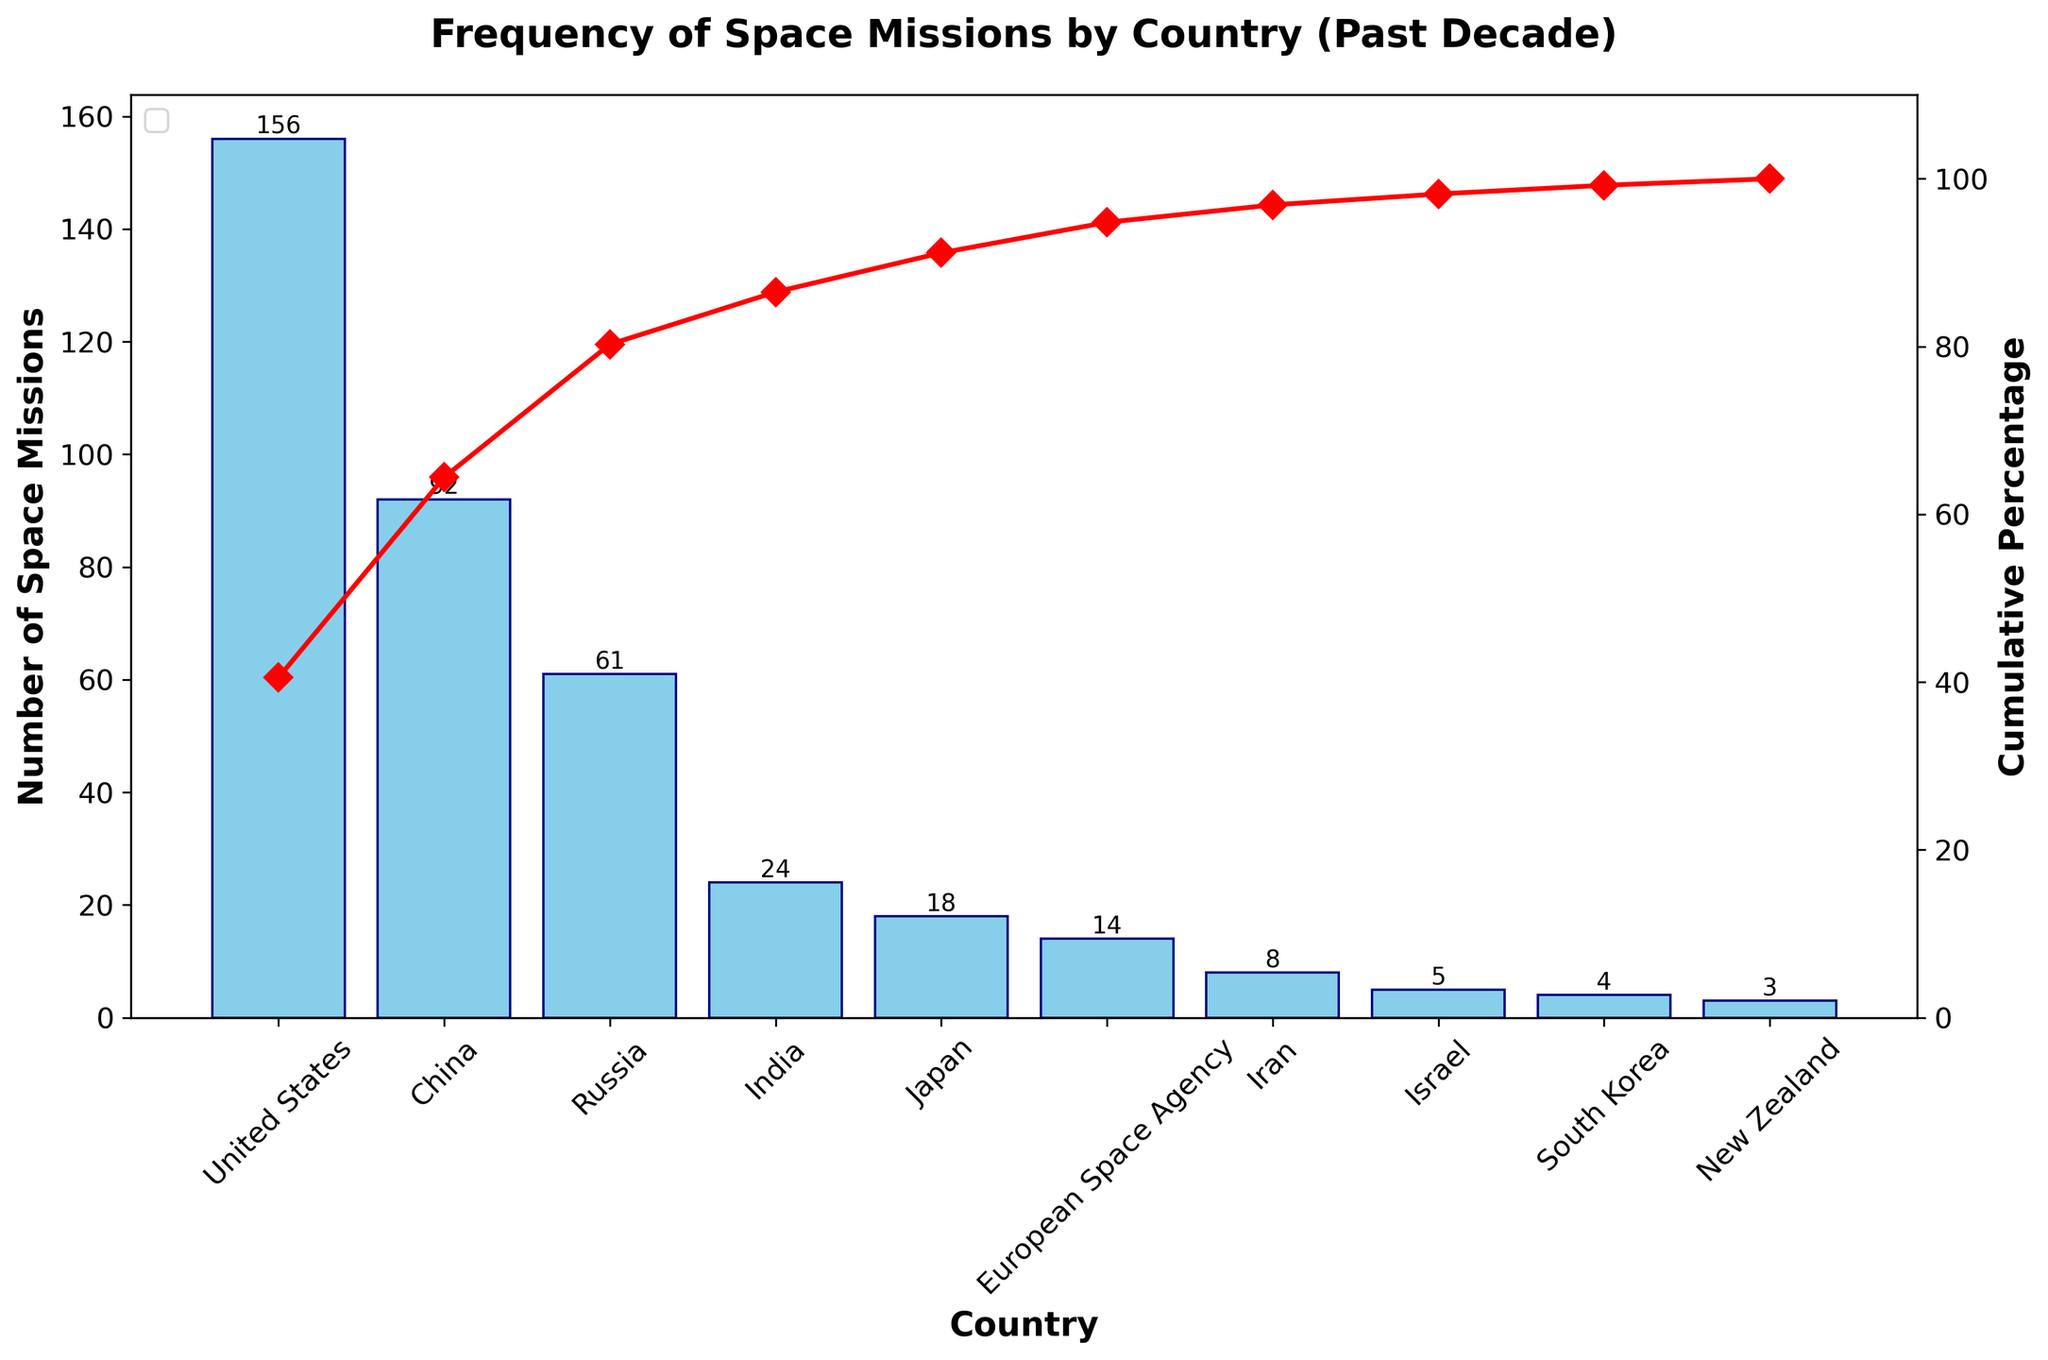How many countries are represented in the chart? Count the number of unique countries listed on the x-axis of the bar chart
Answer: 10 Which country has the highest number of space missions? Identify the tallest bar in the bar chart which corresponds to the United States
Answer: United States What is the cumulative percentage of space missions contributed by the top three countries? Look at the cumulative percentage line and note the value after the third country (Russia), which is the sum of the first three countries' contributions
Answer: 85.25% How many more space missions does China have compared to Russia? Subtract the number of space missions of Russia (61) from that of China (92)
Answer: 31 Which country contributes exactly 14 missions? Find the bar labeled "European Space Agency" which corresponds to 14 missions in the chart
Answer: European Space Agency What is the approximate cumulative percentage after including India? Trace the cumulative percentage line after India on the graph
Answer: ~83% How does the number of space missions of Japan compare to that of India? Look at the bar heights for Japan (18) and India (24) and compare
Answer: India has more missions If we add the missions from New Zealand, South Korea, Israel, and Iran, how many missions is that in total? Sum the missions of New Zealand (3), South Korea (4), Israel (5), and Iran (8)
Answer: 20 At what cumulative percentage does Iran lie? Locate Iran on the x-axis and trace the cumulative percentage line to find the exact percentage
Answer: 92.11% Provide the combined number of missions for Japan and the European Space Agency. Add the missions of Japan (18) and the European Space Agency (14) together
Answer: 32 